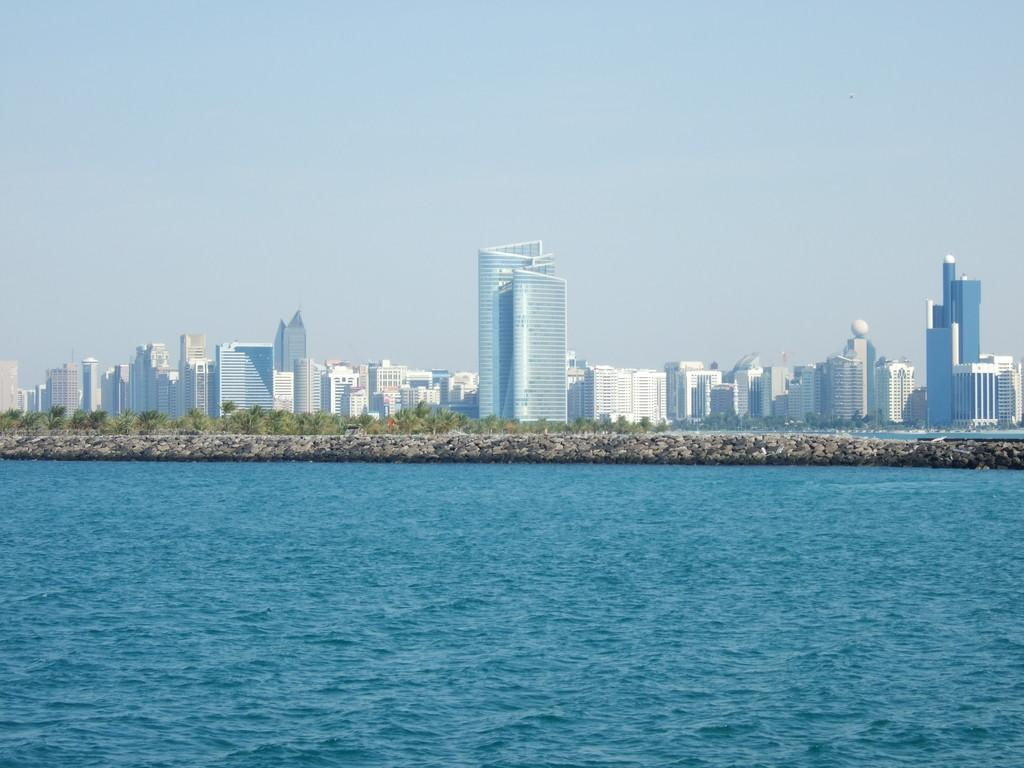What is visible in the image? Water, rocks, trees, buildings, and the sky are visible in the image. Can you describe the natural elements in the image? There are rocks and trees visible in the image. What type of man-made structures can be seen in the image? There are buildings visible in the image. What part of the natural environment is visible in the image? The sky is visible in the background of the image. How many books are stacked on the rocks in the image? There are no books present in the image. What direction are the trees facing in the image? The trees do not have a specific direction they are facing in the image; they are stationary. What type of cord is used to connect the buildings in the image? There is no cord visible connecting the buildings in the image. 